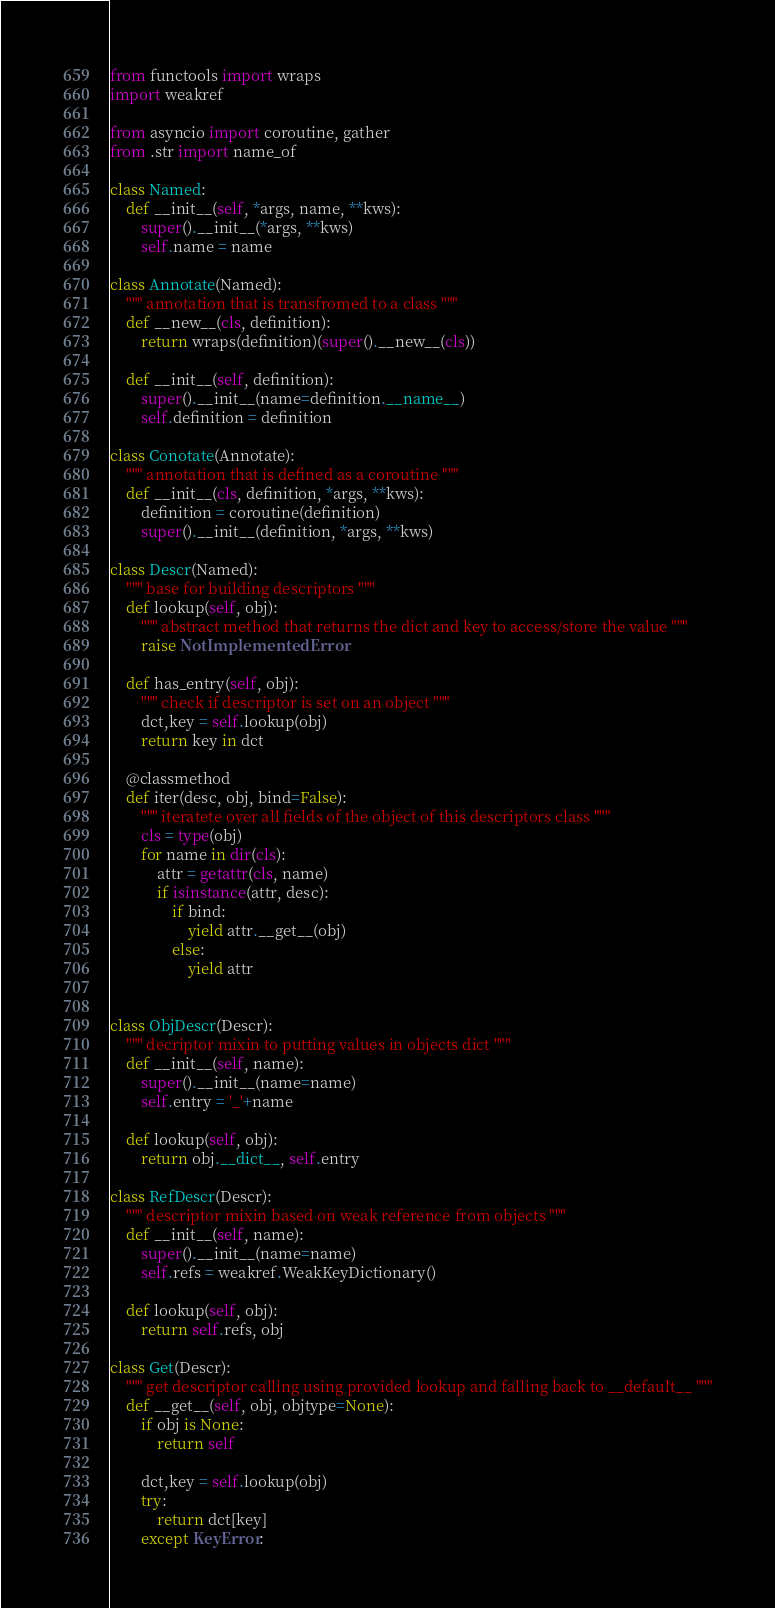<code> <loc_0><loc_0><loc_500><loc_500><_Python_>from functools import wraps
import weakref

from asyncio import coroutine, gather
from .str import name_of

class Named:
    def __init__(self, *args, name, **kws):
        super().__init__(*args, **kws)
        self.name = name

class Annotate(Named):
    """ annotation that is transfromed to a class """
    def __new__(cls, definition):
        return wraps(definition)(super().__new__(cls))

    def __init__(self, definition):
        super().__init__(name=definition.__name__)
        self.definition = definition

class Conotate(Annotate):
    """ annotation that is defined as a coroutine """
    def __init__(cls, definition, *args, **kws):
        definition = coroutine(definition)
        super().__init__(definition, *args, **kws)

class Descr(Named):
    """ base for building descriptors """
    def lookup(self, obj):
        """ abstract method that returns the dict and key to access/store the value """
        raise NotImplementedError

    def has_entry(self, obj):
        """ check if descriptor is set on an object """
        dct,key = self.lookup(obj)
        return key in dct

    @classmethod
    def iter(desc, obj, bind=False):
        """ iteratete over all fields of the object of this descriptors class """
        cls = type(obj)
        for name in dir(cls):
            attr = getattr(cls, name)
            if isinstance(attr, desc):
                if bind:
                    yield attr.__get__(obj)
                else:
                    yield attr


class ObjDescr(Descr):
    """ decriptor mixin to putting values in objects dict """
    def __init__(self, name):
        super().__init__(name=name)
        self.entry = '_'+name

    def lookup(self, obj):
        return obj.__dict__, self.entry

class RefDescr(Descr):
    """ descriptor mixin based on weak reference from objects """
    def __init__(self, name):
        super().__init__(name=name)
        self.refs = weakref.WeakKeyDictionary()

    def lookup(self, obj):
        return self.refs, obj

class Get(Descr):
    """ get descriptor calling using provided lookup and falling back to __default__ """
    def __get__(self, obj, objtype=None):
        if obj is None:
            return self

        dct,key = self.lookup(obj)
        try:
            return dct[key]
        except KeyError:</code> 